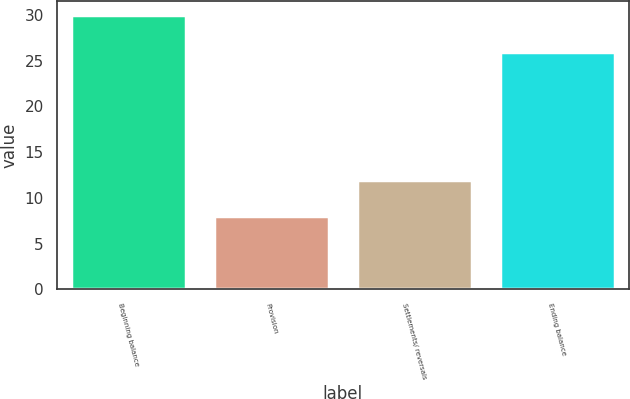<chart> <loc_0><loc_0><loc_500><loc_500><bar_chart><fcel>Beginning balance<fcel>Provision<fcel>Settlements/ reversals<fcel>Ending balance<nl><fcel>30<fcel>8<fcel>12<fcel>26<nl></chart> 